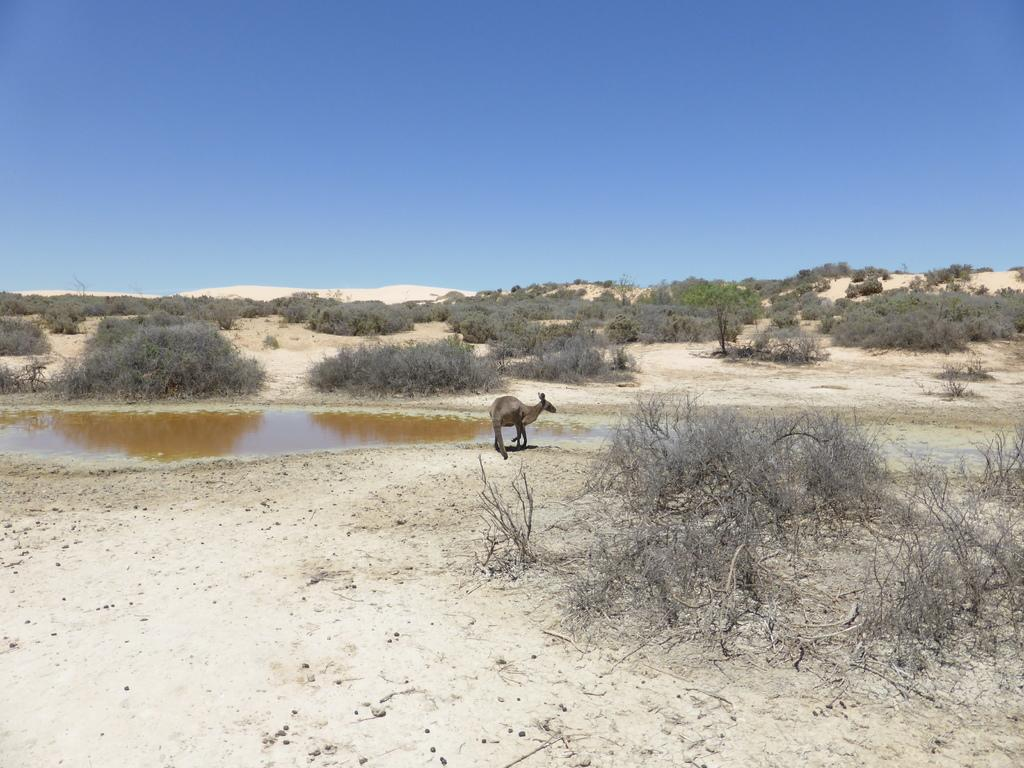What animal is in the picture? There is a kangaroo in the picture. Where is the kangaroo located in relation to the water? The kangaroo is standing near the water. What type of terrain is visible in the picture? There is sand visible in the picture. What type of vegetation is present in the picture? There are trees in the picture. What type of spark can be seen coming from the kangaroo's pouch in the picture? There is no spark visible coming from the kangaroo's pouch in the picture. 